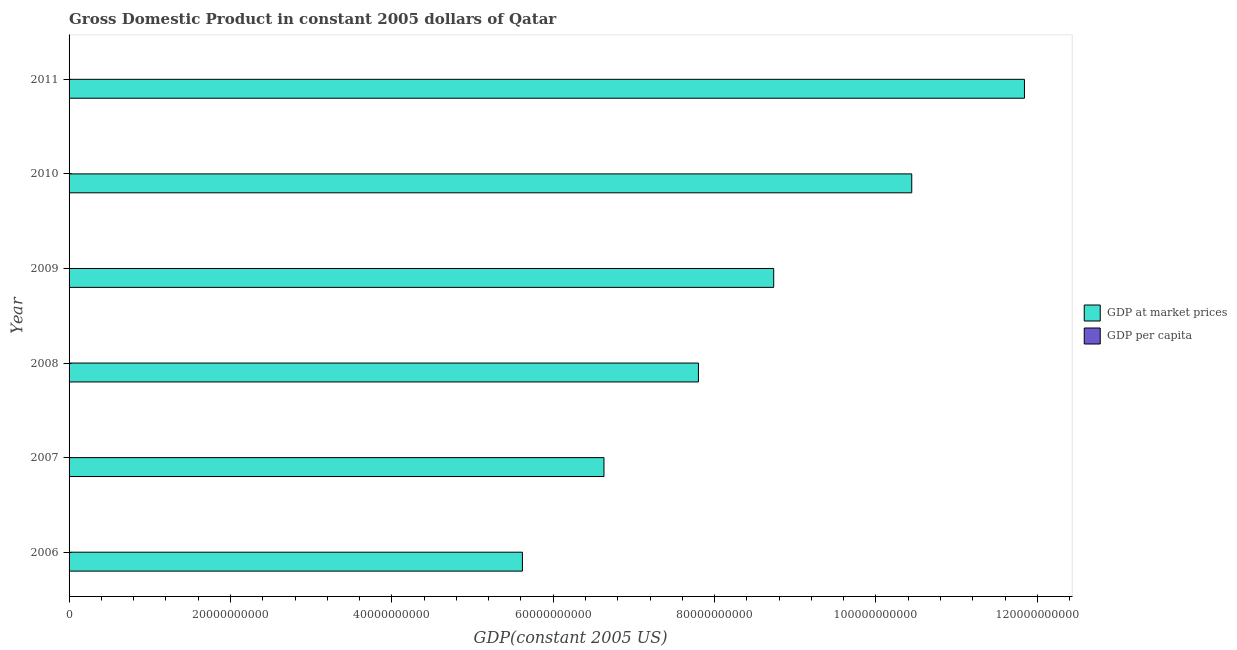How many groups of bars are there?
Give a very brief answer. 6. Are the number of bars per tick equal to the number of legend labels?
Provide a succinct answer. Yes. Are the number of bars on each tick of the Y-axis equal?
Your response must be concise. Yes. In how many cases, is the number of bars for a given year not equal to the number of legend labels?
Make the answer very short. 0. What is the gdp at market prices in 2010?
Your answer should be compact. 1.04e+11. Across all years, what is the maximum gdp at market prices?
Your answer should be compact. 1.18e+11. Across all years, what is the minimum gdp per capita?
Provide a succinct answer. 5.49e+04. In which year was the gdp at market prices maximum?
Give a very brief answer. 2011. What is the total gdp per capita in the graph?
Make the answer very short. 3.45e+05. What is the difference between the gdp per capita in 2007 and that in 2009?
Provide a short and direct response. 1345.97. What is the difference between the gdp per capita in 2011 and the gdp at market prices in 2007?
Ensure brevity in your answer.  -6.63e+1. What is the average gdp at market prices per year?
Give a very brief answer. 8.51e+1. In the year 2006, what is the difference between the gdp per capita and gdp at market prices?
Provide a short and direct response. -5.62e+1. What is the ratio of the gdp at market prices in 2007 to that in 2010?
Offer a very short reply. 0.64. Is the difference between the gdp per capita in 2010 and 2011 greater than the difference between the gdp at market prices in 2010 and 2011?
Ensure brevity in your answer.  Yes. What is the difference between the highest and the second highest gdp per capita?
Offer a very short reply. 2986.91. What is the difference between the highest and the lowest gdp per capita?
Make the answer very short. 7257.44. In how many years, is the gdp at market prices greater than the average gdp at market prices taken over all years?
Offer a very short reply. 3. What does the 2nd bar from the top in 2011 represents?
Offer a very short reply. GDP at market prices. What does the 1st bar from the bottom in 2010 represents?
Provide a short and direct response. GDP at market prices. What is the difference between two consecutive major ticks on the X-axis?
Offer a terse response. 2.00e+1. Does the graph contain any zero values?
Ensure brevity in your answer.  No. Does the graph contain grids?
Provide a short and direct response. No. Where does the legend appear in the graph?
Your answer should be very brief. Center right. How are the legend labels stacked?
Keep it short and to the point. Vertical. What is the title of the graph?
Your response must be concise. Gross Domestic Product in constant 2005 dollars of Qatar. What is the label or title of the X-axis?
Your answer should be compact. GDP(constant 2005 US). What is the label or title of the Y-axis?
Provide a short and direct response. Year. What is the GDP(constant 2005 US) of GDP at market prices in 2006?
Offer a very short reply. 5.62e+1. What is the GDP(constant 2005 US) in GDP per capita in 2006?
Ensure brevity in your answer.  5.68e+04. What is the GDP(constant 2005 US) in GDP at market prices in 2007?
Your answer should be very brief. 6.63e+1. What is the GDP(constant 2005 US) of GDP per capita in 2007?
Offer a very short reply. 5.62e+04. What is the GDP(constant 2005 US) in GDP at market prices in 2008?
Offer a terse response. 7.80e+1. What is the GDP(constant 2005 US) in GDP per capita in 2008?
Ensure brevity in your answer.  5.62e+04. What is the GDP(constant 2005 US) in GDP at market prices in 2009?
Your response must be concise. 8.73e+1. What is the GDP(constant 2005 US) of GDP per capita in 2009?
Give a very brief answer. 5.49e+04. What is the GDP(constant 2005 US) of GDP at market prices in 2010?
Your answer should be very brief. 1.04e+11. What is the GDP(constant 2005 US) of GDP per capita in 2010?
Give a very brief answer. 5.92e+04. What is the GDP(constant 2005 US) in GDP at market prices in 2011?
Offer a very short reply. 1.18e+11. What is the GDP(constant 2005 US) in GDP per capita in 2011?
Your answer should be compact. 6.21e+04. Across all years, what is the maximum GDP(constant 2005 US) in GDP at market prices?
Give a very brief answer. 1.18e+11. Across all years, what is the maximum GDP(constant 2005 US) of GDP per capita?
Your answer should be very brief. 6.21e+04. Across all years, what is the minimum GDP(constant 2005 US) of GDP at market prices?
Offer a terse response. 5.62e+1. Across all years, what is the minimum GDP(constant 2005 US) in GDP per capita?
Give a very brief answer. 5.49e+04. What is the total GDP(constant 2005 US) of GDP at market prices in the graph?
Your answer should be very brief. 5.11e+11. What is the total GDP(constant 2005 US) of GDP per capita in the graph?
Provide a short and direct response. 3.45e+05. What is the difference between the GDP(constant 2005 US) in GDP at market prices in 2006 and that in 2007?
Make the answer very short. -1.01e+1. What is the difference between the GDP(constant 2005 US) of GDP per capita in 2006 and that in 2007?
Your answer should be compact. 613.66. What is the difference between the GDP(constant 2005 US) in GDP at market prices in 2006 and that in 2008?
Your response must be concise. -2.18e+1. What is the difference between the GDP(constant 2005 US) in GDP per capita in 2006 and that in 2008?
Provide a succinct answer. 684.97. What is the difference between the GDP(constant 2005 US) in GDP at market prices in 2006 and that in 2009?
Provide a short and direct response. -3.11e+1. What is the difference between the GDP(constant 2005 US) of GDP per capita in 2006 and that in 2009?
Provide a succinct answer. 1959.63. What is the difference between the GDP(constant 2005 US) in GDP at market prices in 2006 and that in 2010?
Provide a short and direct response. -4.82e+1. What is the difference between the GDP(constant 2005 US) in GDP per capita in 2006 and that in 2010?
Keep it short and to the point. -2310.89. What is the difference between the GDP(constant 2005 US) in GDP at market prices in 2006 and that in 2011?
Keep it short and to the point. -6.22e+1. What is the difference between the GDP(constant 2005 US) in GDP per capita in 2006 and that in 2011?
Provide a short and direct response. -5297.8. What is the difference between the GDP(constant 2005 US) of GDP at market prices in 2007 and that in 2008?
Provide a short and direct response. -1.17e+1. What is the difference between the GDP(constant 2005 US) of GDP per capita in 2007 and that in 2008?
Give a very brief answer. 71.31. What is the difference between the GDP(constant 2005 US) of GDP at market prices in 2007 and that in 2009?
Provide a short and direct response. -2.10e+1. What is the difference between the GDP(constant 2005 US) of GDP per capita in 2007 and that in 2009?
Your answer should be very brief. 1345.97. What is the difference between the GDP(constant 2005 US) in GDP at market prices in 2007 and that in 2010?
Ensure brevity in your answer.  -3.81e+1. What is the difference between the GDP(constant 2005 US) of GDP per capita in 2007 and that in 2010?
Your answer should be very brief. -2924.55. What is the difference between the GDP(constant 2005 US) in GDP at market prices in 2007 and that in 2011?
Ensure brevity in your answer.  -5.21e+1. What is the difference between the GDP(constant 2005 US) of GDP per capita in 2007 and that in 2011?
Give a very brief answer. -5911.47. What is the difference between the GDP(constant 2005 US) of GDP at market prices in 2008 and that in 2009?
Your answer should be compact. -9.33e+09. What is the difference between the GDP(constant 2005 US) in GDP per capita in 2008 and that in 2009?
Offer a very short reply. 1274.66. What is the difference between the GDP(constant 2005 US) in GDP at market prices in 2008 and that in 2010?
Offer a terse response. -2.64e+1. What is the difference between the GDP(constant 2005 US) in GDP per capita in 2008 and that in 2010?
Give a very brief answer. -2995.87. What is the difference between the GDP(constant 2005 US) of GDP at market prices in 2008 and that in 2011?
Your response must be concise. -4.04e+1. What is the difference between the GDP(constant 2005 US) of GDP per capita in 2008 and that in 2011?
Offer a very short reply. -5982.78. What is the difference between the GDP(constant 2005 US) in GDP at market prices in 2009 and that in 2010?
Provide a short and direct response. -1.71e+1. What is the difference between the GDP(constant 2005 US) of GDP per capita in 2009 and that in 2010?
Your answer should be compact. -4270.53. What is the difference between the GDP(constant 2005 US) of GDP at market prices in 2009 and that in 2011?
Provide a short and direct response. -3.11e+1. What is the difference between the GDP(constant 2005 US) in GDP per capita in 2009 and that in 2011?
Provide a short and direct response. -7257.44. What is the difference between the GDP(constant 2005 US) in GDP at market prices in 2010 and that in 2011?
Your response must be concise. -1.40e+1. What is the difference between the GDP(constant 2005 US) in GDP per capita in 2010 and that in 2011?
Your answer should be very brief. -2986.91. What is the difference between the GDP(constant 2005 US) in GDP at market prices in 2006 and the GDP(constant 2005 US) in GDP per capita in 2007?
Your response must be concise. 5.62e+1. What is the difference between the GDP(constant 2005 US) of GDP at market prices in 2006 and the GDP(constant 2005 US) of GDP per capita in 2008?
Provide a short and direct response. 5.62e+1. What is the difference between the GDP(constant 2005 US) in GDP at market prices in 2006 and the GDP(constant 2005 US) in GDP per capita in 2009?
Offer a very short reply. 5.62e+1. What is the difference between the GDP(constant 2005 US) of GDP at market prices in 2006 and the GDP(constant 2005 US) of GDP per capita in 2010?
Keep it short and to the point. 5.62e+1. What is the difference between the GDP(constant 2005 US) of GDP at market prices in 2006 and the GDP(constant 2005 US) of GDP per capita in 2011?
Keep it short and to the point. 5.62e+1. What is the difference between the GDP(constant 2005 US) of GDP at market prices in 2007 and the GDP(constant 2005 US) of GDP per capita in 2008?
Offer a terse response. 6.63e+1. What is the difference between the GDP(constant 2005 US) of GDP at market prices in 2007 and the GDP(constant 2005 US) of GDP per capita in 2009?
Provide a succinct answer. 6.63e+1. What is the difference between the GDP(constant 2005 US) of GDP at market prices in 2007 and the GDP(constant 2005 US) of GDP per capita in 2010?
Your response must be concise. 6.63e+1. What is the difference between the GDP(constant 2005 US) of GDP at market prices in 2007 and the GDP(constant 2005 US) of GDP per capita in 2011?
Keep it short and to the point. 6.63e+1. What is the difference between the GDP(constant 2005 US) in GDP at market prices in 2008 and the GDP(constant 2005 US) in GDP per capita in 2009?
Provide a succinct answer. 7.80e+1. What is the difference between the GDP(constant 2005 US) in GDP at market prices in 2008 and the GDP(constant 2005 US) in GDP per capita in 2010?
Provide a short and direct response. 7.80e+1. What is the difference between the GDP(constant 2005 US) in GDP at market prices in 2008 and the GDP(constant 2005 US) in GDP per capita in 2011?
Provide a succinct answer. 7.80e+1. What is the difference between the GDP(constant 2005 US) in GDP at market prices in 2009 and the GDP(constant 2005 US) in GDP per capita in 2010?
Offer a very short reply. 8.73e+1. What is the difference between the GDP(constant 2005 US) of GDP at market prices in 2009 and the GDP(constant 2005 US) of GDP per capita in 2011?
Your answer should be compact. 8.73e+1. What is the difference between the GDP(constant 2005 US) of GDP at market prices in 2010 and the GDP(constant 2005 US) of GDP per capita in 2011?
Provide a short and direct response. 1.04e+11. What is the average GDP(constant 2005 US) in GDP at market prices per year?
Offer a very short reply. 8.51e+1. What is the average GDP(constant 2005 US) in GDP per capita per year?
Make the answer very short. 5.76e+04. In the year 2006, what is the difference between the GDP(constant 2005 US) in GDP at market prices and GDP(constant 2005 US) in GDP per capita?
Provide a succinct answer. 5.62e+1. In the year 2007, what is the difference between the GDP(constant 2005 US) of GDP at market prices and GDP(constant 2005 US) of GDP per capita?
Keep it short and to the point. 6.63e+1. In the year 2008, what is the difference between the GDP(constant 2005 US) of GDP at market prices and GDP(constant 2005 US) of GDP per capita?
Your answer should be compact. 7.80e+1. In the year 2009, what is the difference between the GDP(constant 2005 US) in GDP at market prices and GDP(constant 2005 US) in GDP per capita?
Offer a terse response. 8.73e+1. In the year 2010, what is the difference between the GDP(constant 2005 US) of GDP at market prices and GDP(constant 2005 US) of GDP per capita?
Give a very brief answer. 1.04e+11. In the year 2011, what is the difference between the GDP(constant 2005 US) of GDP at market prices and GDP(constant 2005 US) of GDP per capita?
Your response must be concise. 1.18e+11. What is the ratio of the GDP(constant 2005 US) in GDP at market prices in 2006 to that in 2007?
Keep it short and to the point. 0.85. What is the ratio of the GDP(constant 2005 US) in GDP per capita in 2006 to that in 2007?
Your answer should be compact. 1.01. What is the ratio of the GDP(constant 2005 US) in GDP at market prices in 2006 to that in 2008?
Your answer should be compact. 0.72. What is the ratio of the GDP(constant 2005 US) in GDP per capita in 2006 to that in 2008?
Provide a succinct answer. 1.01. What is the ratio of the GDP(constant 2005 US) of GDP at market prices in 2006 to that in 2009?
Offer a terse response. 0.64. What is the ratio of the GDP(constant 2005 US) of GDP per capita in 2006 to that in 2009?
Make the answer very short. 1.04. What is the ratio of the GDP(constant 2005 US) in GDP at market prices in 2006 to that in 2010?
Give a very brief answer. 0.54. What is the ratio of the GDP(constant 2005 US) in GDP per capita in 2006 to that in 2010?
Your answer should be very brief. 0.96. What is the ratio of the GDP(constant 2005 US) in GDP at market prices in 2006 to that in 2011?
Your answer should be very brief. 0.47. What is the ratio of the GDP(constant 2005 US) of GDP per capita in 2006 to that in 2011?
Offer a terse response. 0.91. What is the ratio of the GDP(constant 2005 US) of GDP at market prices in 2007 to that in 2008?
Keep it short and to the point. 0.85. What is the ratio of the GDP(constant 2005 US) in GDP per capita in 2007 to that in 2008?
Your answer should be very brief. 1. What is the ratio of the GDP(constant 2005 US) in GDP at market prices in 2007 to that in 2009?
Offer a terse response. 0.76. What is the ratio of the GDP(constant 2005 US) of GDP per capita in 2007 to that in 2009?
Your response must be concise. 1.02. What is the ratio of the GDP(constant 2005 US) of GDP at market prices in 2007 to that in 2010?
Offer a very short reply. 0.63. What is the ratio of the GDP(constant 2005 US) in GDP per capita in 2007 to that in 2010?
Offer a terse response. 0.95. What is the ratio of the GDP(constant 2005 US) of GDP at market prices in 2007 to that in 2011?
Provide a succinct answer. 0.56. What is the ratio of the GDP(constant 2005 US) in GDP per capita in 2007 to that in 2011?
Offer a terse response. 0.9. What is the ratio of the GDP(constant 2005 US) in GDP at market prices in 2008 to that in 2009?
Provide a short and direct response. 0.89. What is the ratio of the GDP(constant 2005 US) in GDP per capita in 2008 to that in 2009?
Your response must be concise. 1.02. What is the ratio of the GDP(constant 2005 US) in GDP at market prices in 2008 to that in 2010?
Your answer should be compact. 0.75. What is the ratio of the GDP(constant 2005 US) of GDP per capita in 2008 to that in 2010?
Offer a terse response. 0.95. What is the ratio of the GDP(constant 2005 US) in GDP at market prices in 2008 to that in 2011?
Provide a succinct answer. 0.66. What is the ratio of the GDP(constant 2005 US) in GDP per capita in 2008 to that in 2011?
Keep it short and to the point. 0.9. What is the ratio of the GDP(constant 2005 US) of GDP at market prices in 2009 to that in 2010?
Offer a very short reply. 0.84. What is the ratio of the GDP(constant 2005 US) of GDP per capita in 2009 to that in 2010?
Keep it short and to the point. 0.93. What is the ratio of the GDP(constant 2005 US) of GDP at market prices in 2009 to that in 2011?
Offer a very short reply. 0.74. What is the ratio of the GDP(constant 2005 US) in GDP per capita in 2009 to that in 2011?
Your answer should be compact. 0.88. What is the ratio of the GDP(constant 2005 US) in GDP at market prices in 2010 to that in 2011?
Provide a succinct answer. 0.88. What is the ratio of the GDP(constant 2005 US) in GDP per capita in 2010 to that in 2011?
Give a very brief answer. 0.95. What is the difference between the highest and the second highest GDP(constant 2005 US) in GDP at market prices?
Ensure brevity in your answer.  1.40e+1. What is the difference between the highest and the second highest GDP(constant 2005 US) of GDP per capita?
Provide a short and direct response. 2986.91. What is the difference between the highest and the lowest GDP(constant 2005 US) of GDP at market prices?
Keep it short and to the point. 6.22e+1. What is the difference between the highest and the lowest GDP(constant 2005 US) of GDP per capita?
Provide a succinct answer. 7257.44. 